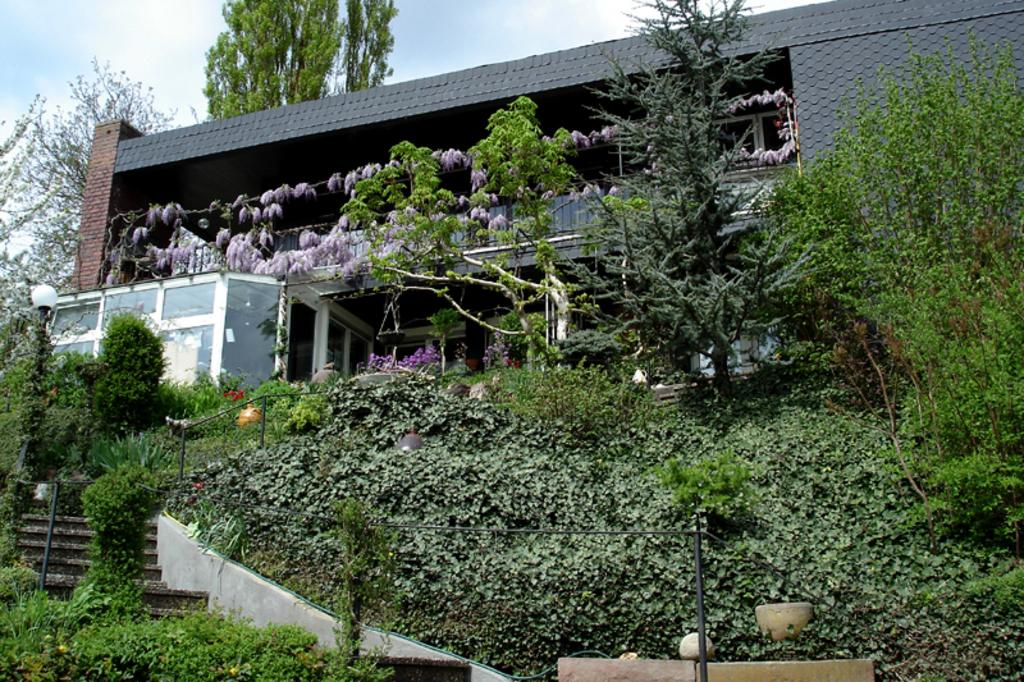What type of structure is present in the image? There is a building in the image. What other natural elements can be seen in the image? There are trees in the image. How would you describe the sky in the image? The sky is blue and cloudy in the image. What celestial objects are visible in the image? Stars are visible in the image. What type of lighting is present in the image? There are pole lights in the image. Where is the zebra standing in the image? There is no zebra present in the image. What type of ice can be seen melting on the building in the image? There is no ice present in the image, and the building does not appear to have any ice on it. 